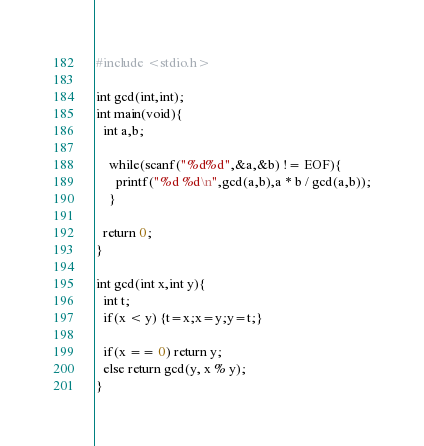Convert code to text. <code><loc_0><loc_0><loc_500><loc_500><_C_>#include <stdio.h>

int gcd(int,int);
int main(void){
  int a,b;

    while(scanf("%d%d",&a,&b) != EOF){
      printf("%d %d\n",gcd(a,b),a * b / gcd(a,b));
    }

  return 0;
}

int gcd(int x,int y){
  int t;
  if(x < y) {t=x;x=y;y=t;}

  if(x == 0) return y;
  else return gcd(y, x % y);
}</code> 